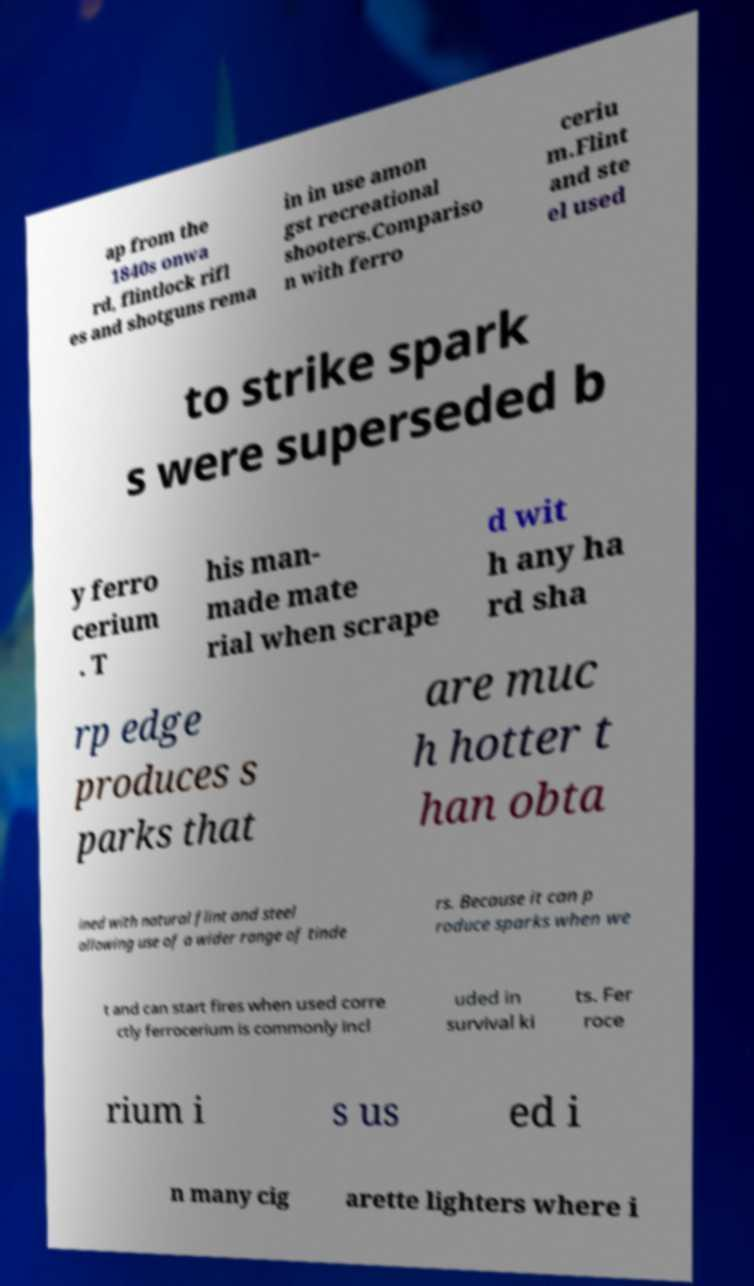Please read and relay the text visible in this image. What does it say? ap from the 1840s onwa rd, flintlock rifl es and shotguns rema in in use amon gst recreational shooters.Compariso n with ferro ceriu m.Flint and ste el used to strike spark s were superseded b y ferro cerium . T his man- made mate rial when scrape d wit h any ha rd sha rp edge produces s parks that are muc h hotter t han obta ined with natural flint and steel allowing use of a wider range of tinde rs. Because it can p roduce sparks when we t and can start fires when used corre ctly ferrocerium is commonly incl uded in survival ki ts. Fer roce rium i s us ed i n many cig arette lighters where i 